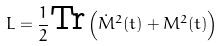Convert formula to latex. <formula><loc_0><loc_0><loc_500><loc_500>L = \frac { 1 } { 2 } \text {Tr} \left ( \dot { M } ^ { 2 } ( t ) + M ^ { 2 } ( t ) \right )</formula> 